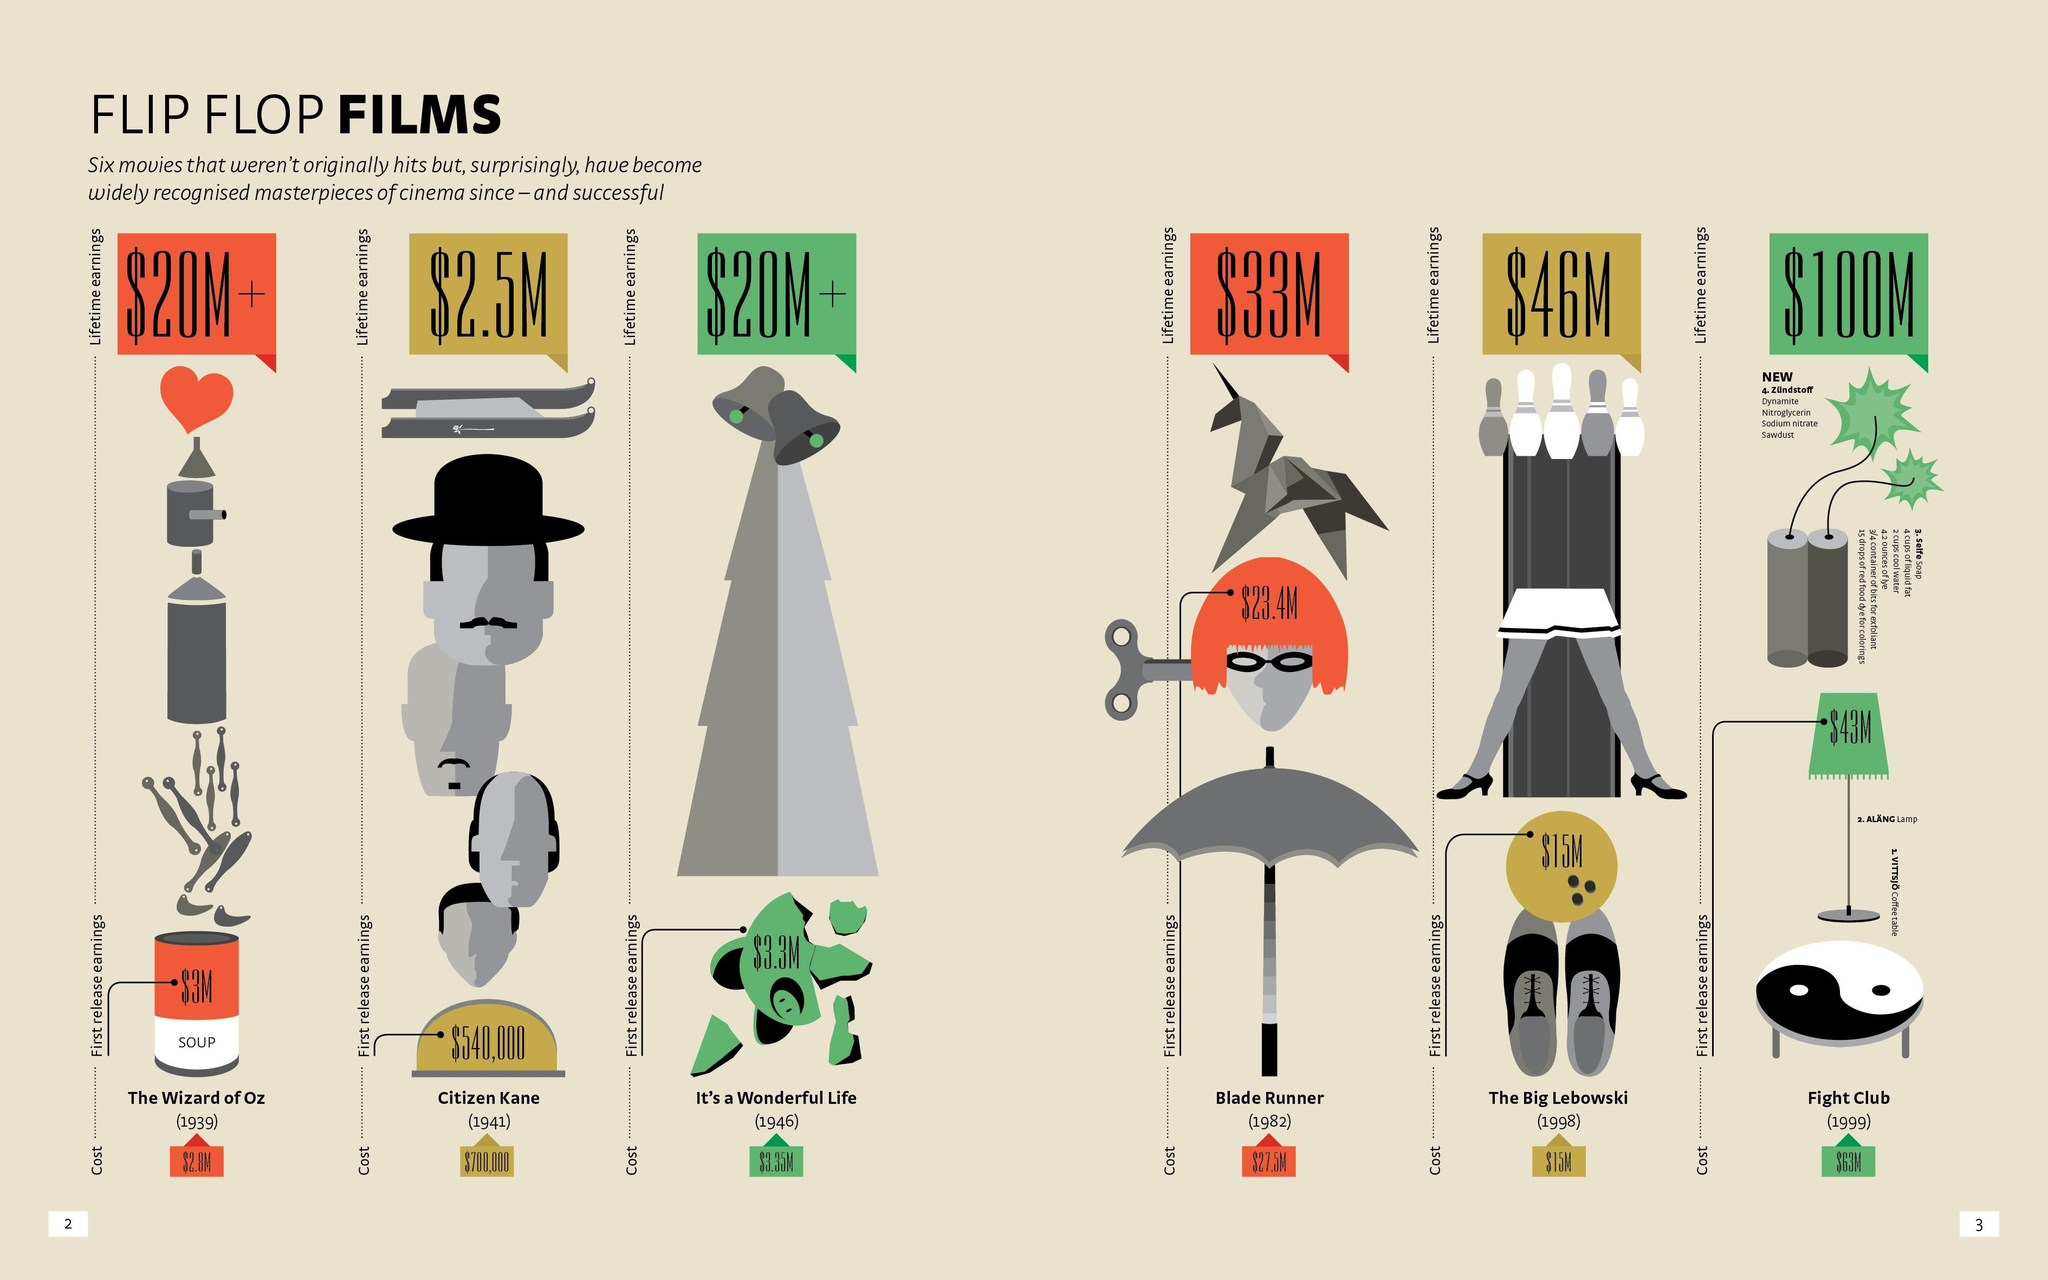What was the highest movie cost incurred ?
Answer the question with a short phrase. $63 M What was initial making cost of the movie with a which had a lifetime earning of $2.5 M? $3.35M When was the movie the blade runner made, 1946, 1982, or 1998? 1982 Which movie has the highest lifetime earnings? Fight Club What was the life time earning  of a movie which had first release earnings of $15M? $46 M What was the lowest cost incurred for making a masterpiece movie? $700,000 Which movie has the an equal making cost and first release earnings? The Big Lebowski What was the lifetime earnings of the movies 'The wizard of  Oz' and 'It's a wonderful Life'? $20 M+ 